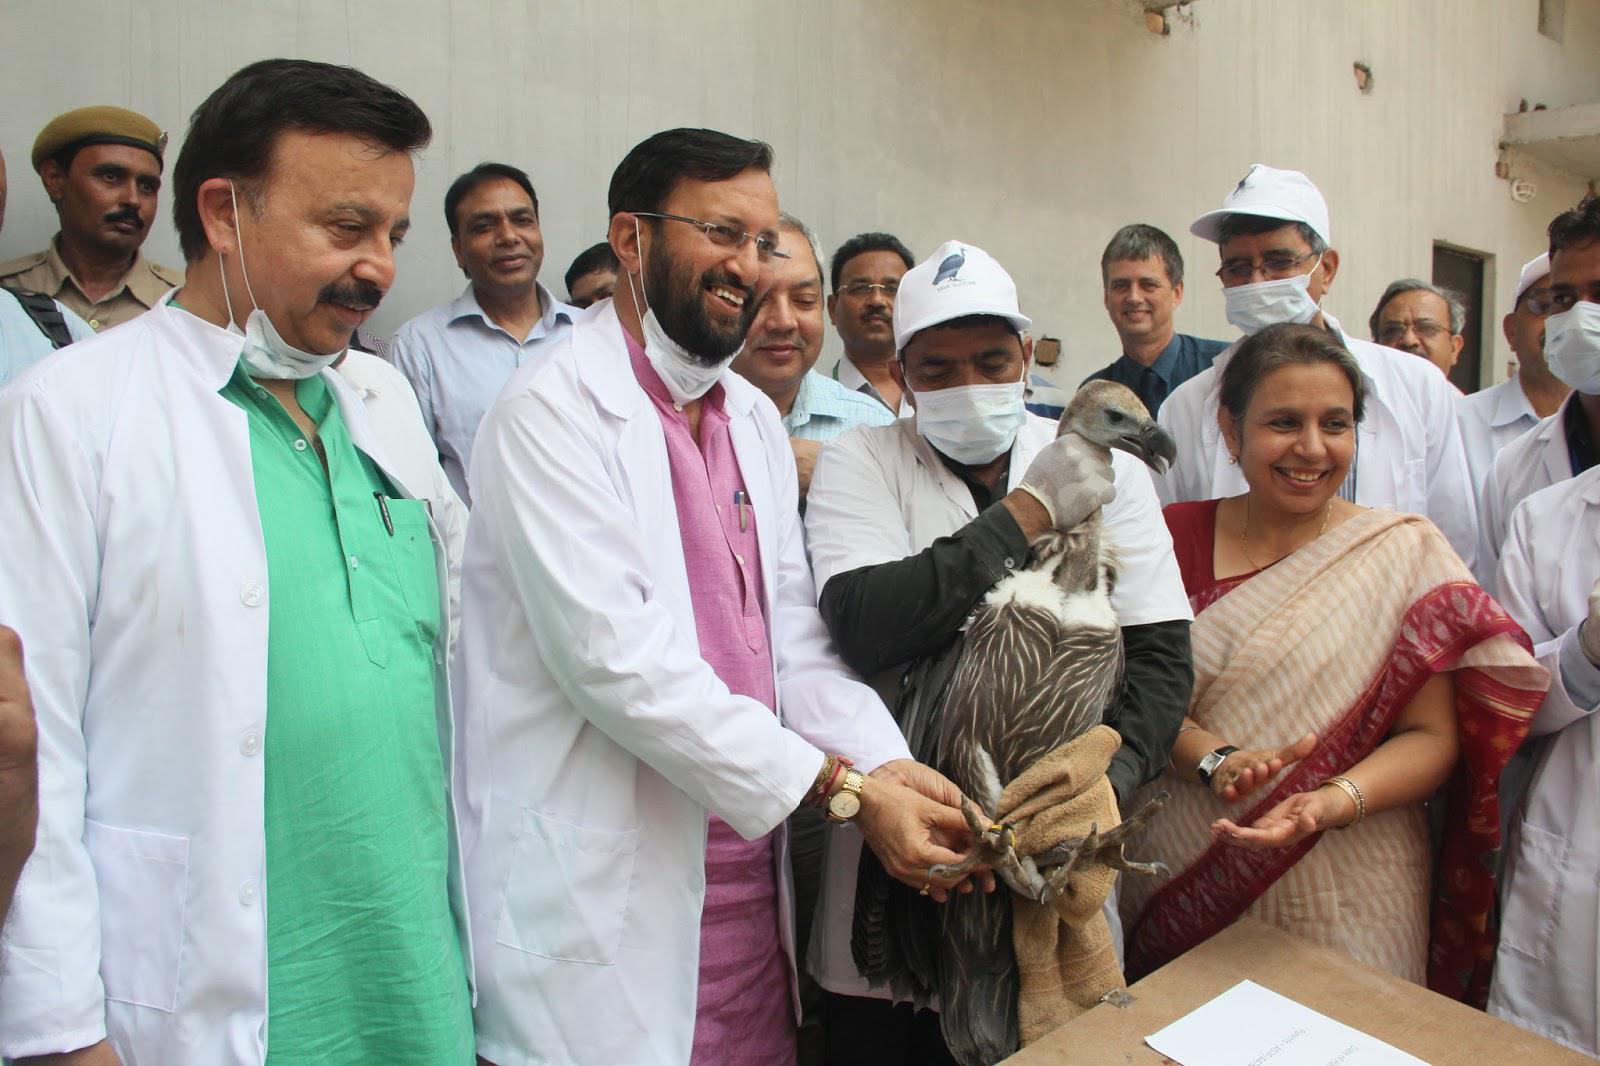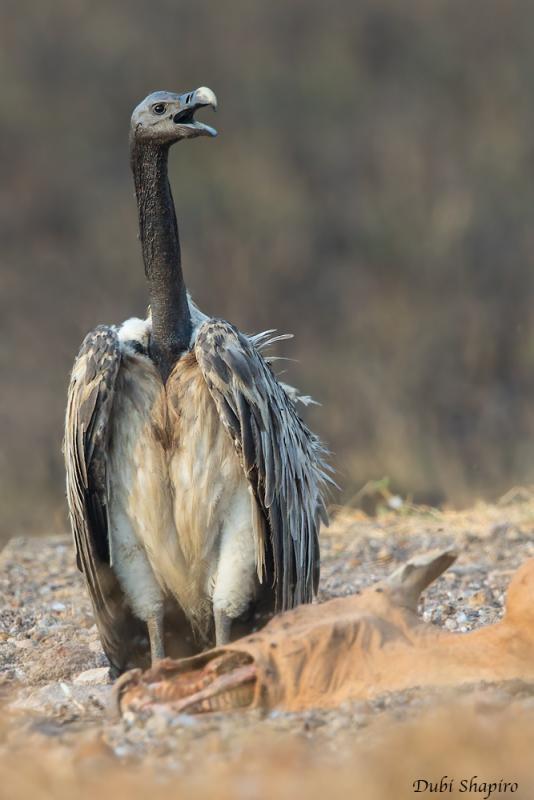The first image is the image on the left, the second image is the image on the right. Assess this claim about the two images: "An image shows one vulture with outspread wings, but it is not in flight off the ground.". Correct or not? Answer yes or no. No. The first image is the image on the left, the second image is the image on the right. Considering the images on both sides, is "The bird in the left image is looking towards the left." valid? Answer yes or no. No. 